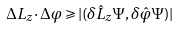Convert formula to latex. <formula><loc_0><loc_0><loc_500><loc_500>\Delta L _ { z } \cdot \Delta \varphi \geqslant | ( \delta \hat { L } _ { z } \Psi , \delta \hat { \varphi } \Psi ) |</formula> 